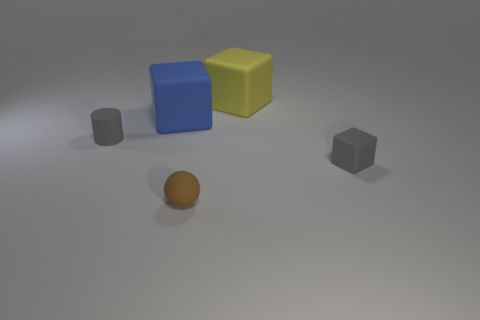Add 1 big blue things. How many objects exist? 6 Subtract all cylinders. How many objects are left? 4 Add 3 blue matte objects. How many blue matte objects exist? 4 Subtract 0 purple cylinders. How many objects are left? 5 Subtract all tiny cylinders. Subtract all brown rubber balls. How many objects are left? 3 Add 1 brown matte things. How many brown matte things are left? 2 